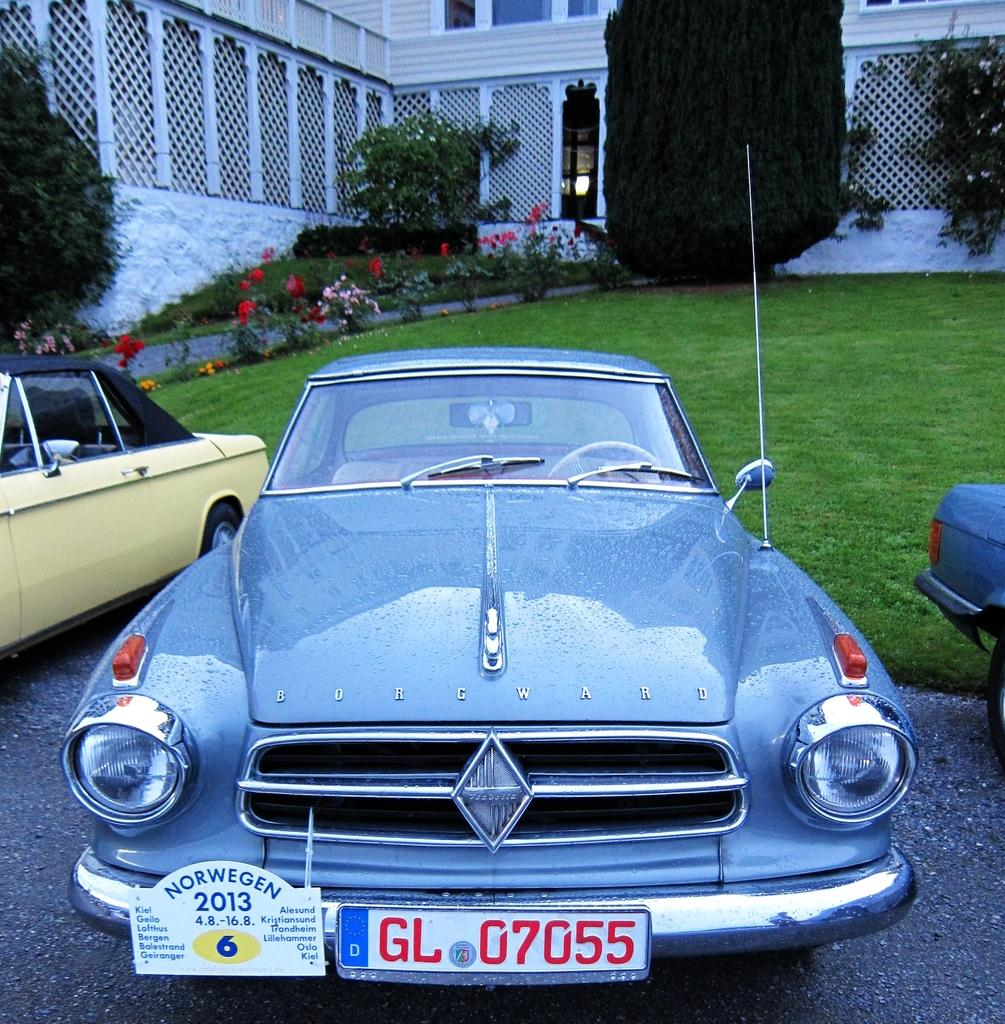How many cars are visible in the foreground of the image? There are three cars in the foreground of the image. Where are the cars located? The cars are on the road. What can be seen in the background of the image? In the background of the image, there are flowers, plants, grass, trees, and a building. Is there any quicksand visible in the image? No, there is no quicksand present in the image. What action are the cars performing in the image? The cars are not performing any actions in the image; they are simply parked or driving on the road. 